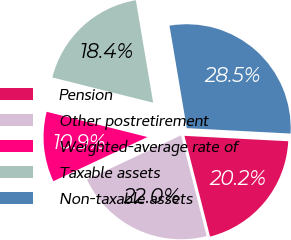Convert chart to OTSL. <chart><loc_0><loc_0><loc_500><loc_500><pie_chart><fcel>Pension<fcel>Other postretirement<fcel>Weighted-average rate of<fcel>Taxable assets<fcel>Non-taxable assets<nl><fcel>20.21%<fcel>21.98%<fcel>10.89%<fcel>18.43%<fcel>28.49%<nl></chart> 